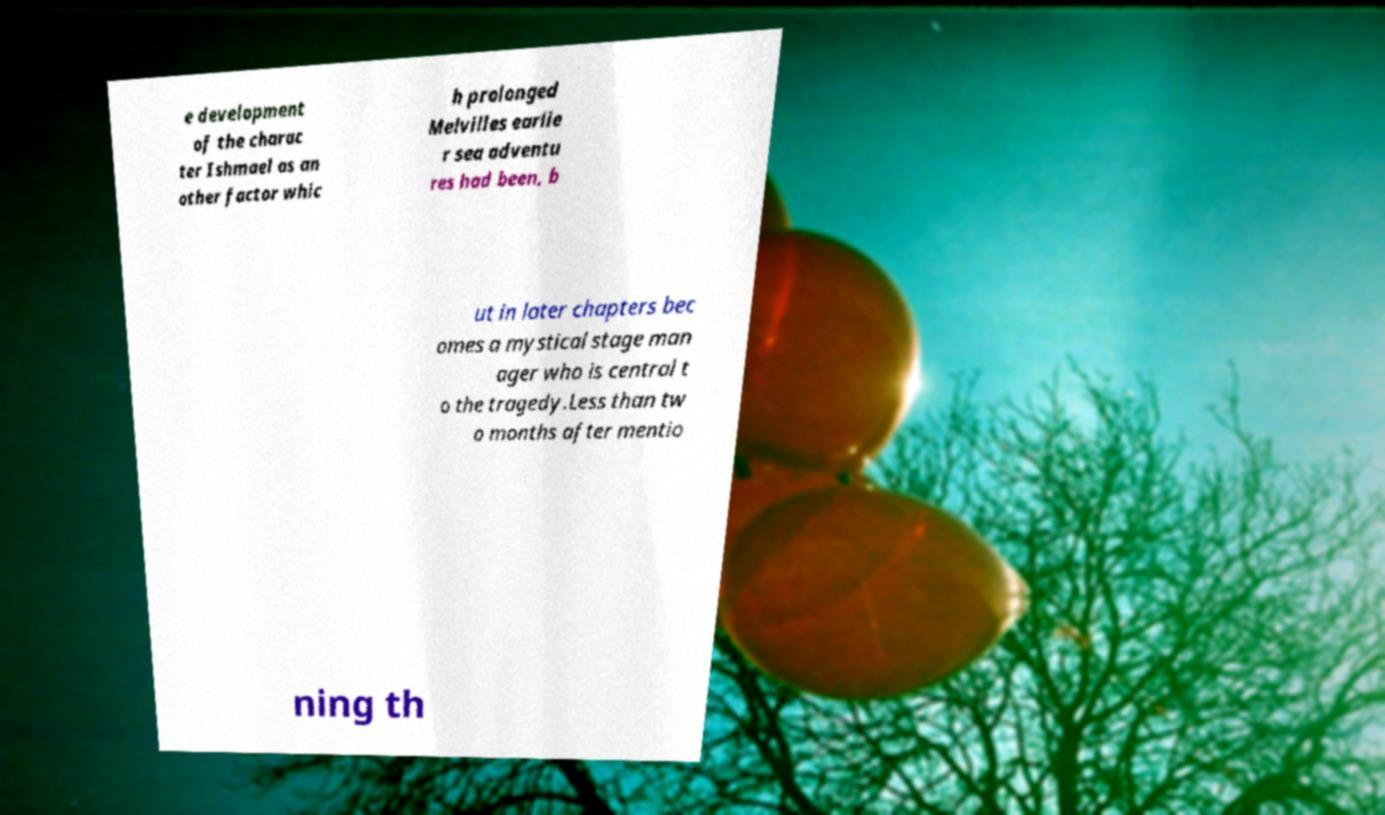For documentation purposes, I need the text within this image transcribed. Could you provide that? e development of the charac ter Ishmael as an other factor whic h prolonged Melvilles earlie r sea adventu res had been, b ut in later chapters bec omes a mystical stage man ager who is central t o the tragedy.Less than tw o months after mentio ning th 